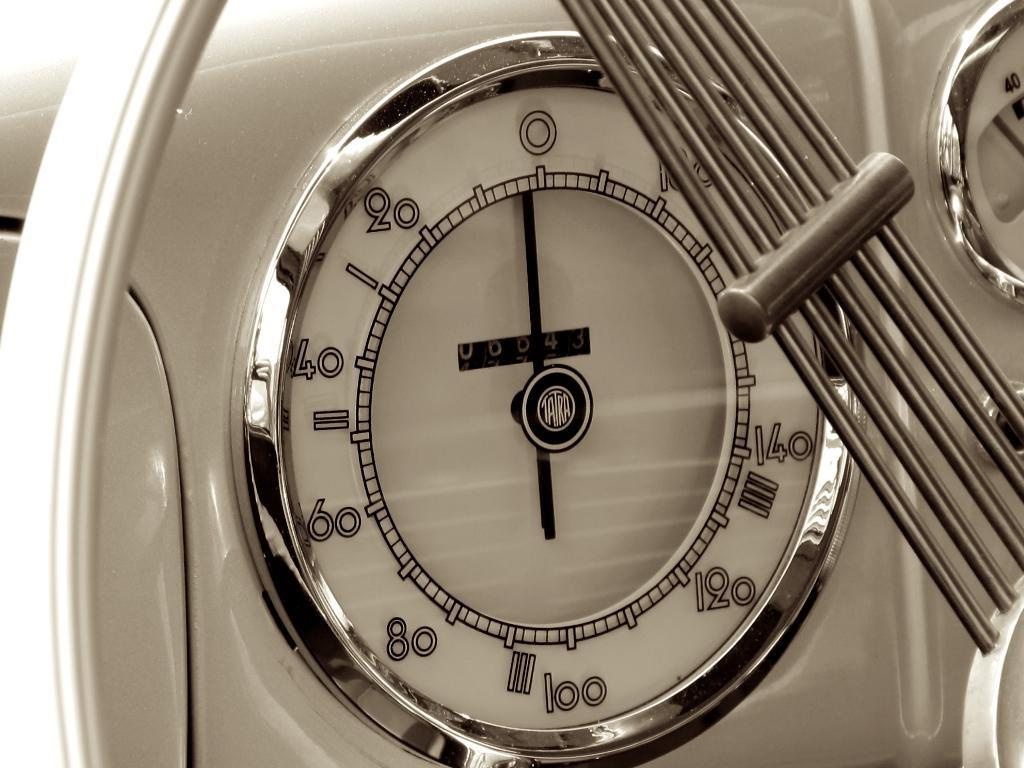<image>
Describe the image concisely. A white Tatra speedometer is set to 0. 